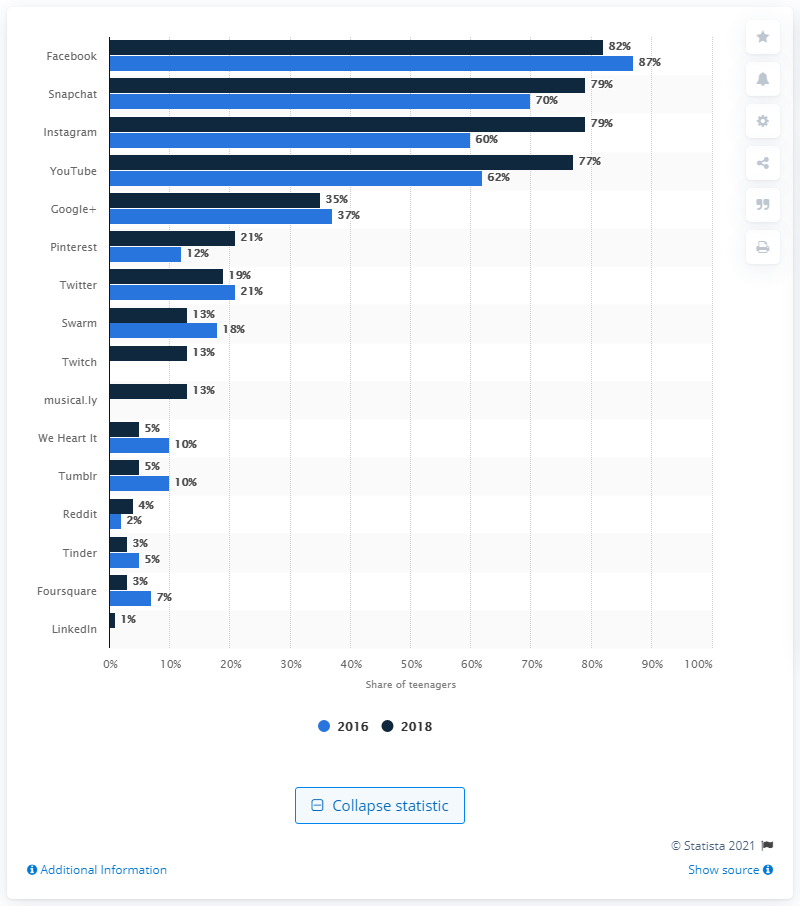Draw attention to some important aspects in this diagram. In 2018, Facebook was the most widely used app, with the highest level of usage among all similar apps. Instagram has become more popular in the Dutch-speaking region of Belgium than any other app. 